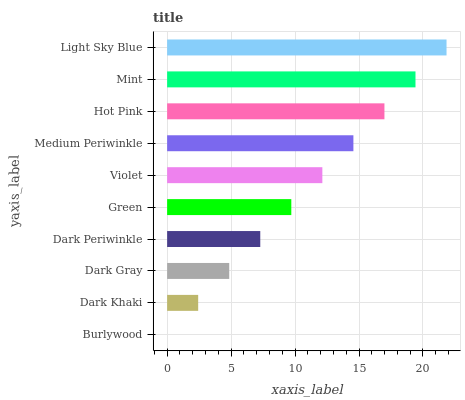Is Burlywood the minimum?
Answer yes or no. Yes. Is Light Sky Blue the maximum?
Answer yes or no. Yes. Is Dark Khaki the minimum?
Answer yes or no. No. Is Dark Khaki the maximum?
Answer yes or no. No. Is Dark Khaki greater than Burlywood?
Answer yes or no. Yes. Is Burlywood less than Dark Khaki?
Answer yes or no. Yes. Is Burlywood greater than Dark Khaki?
Answer yes or no. No. Is Dark Khaki less than Burlywood?
Answer yes or no. No. Is Violet the high median?
Answer yes or no. Yes. Is Green the low median?
Answer yes or no. Yes. Is Light Sky Blue the high median?
Answer yes or no. No. Is Hot Pink the low median?
Answer yes or no. No. 